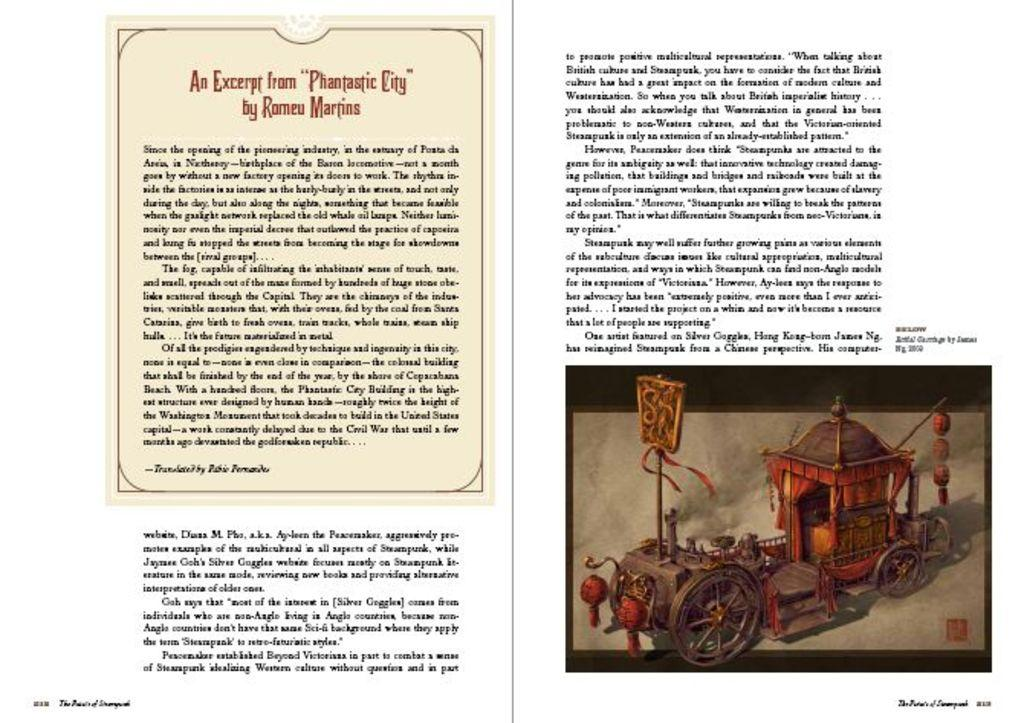What can be seen on the poster in the image? Unfortunately, we cannot determine the content of the poster from the given facts. What is located in the bottom right of the image? There is a chariot in the bottom right of the image. What is on the left side of the image? There is an article on the left side of the image. What type of oatmeal is being served on the shirt in the image? There is no shirt or oatmeal present in the image; the facts only mention a poster and a chariot. 